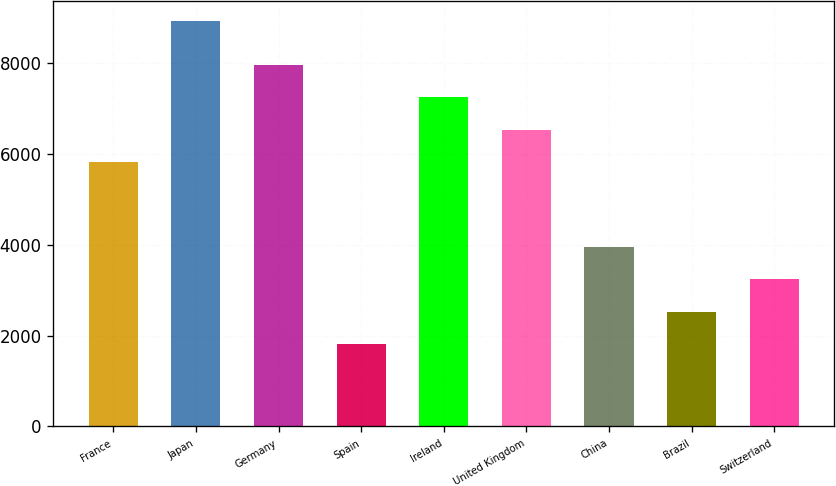<chart> <loc_0><loc_0><loc_500><loc_500><bar_chart><fcel>France<fcel>Japan<fcel>Germany<fcel>Spain<fcel>Ireland<fcel>United Kingdom<fcel>China<fcel>Brazil<fcel>Switzerland<nl><fcel>5819<fcel>8908<fcel>7946.6<fcel>1816<fcel>7237.4<fcel>6528.2<fcel>3943.6<fcel>2525.2<fcel>3234.4<nl></chart> 